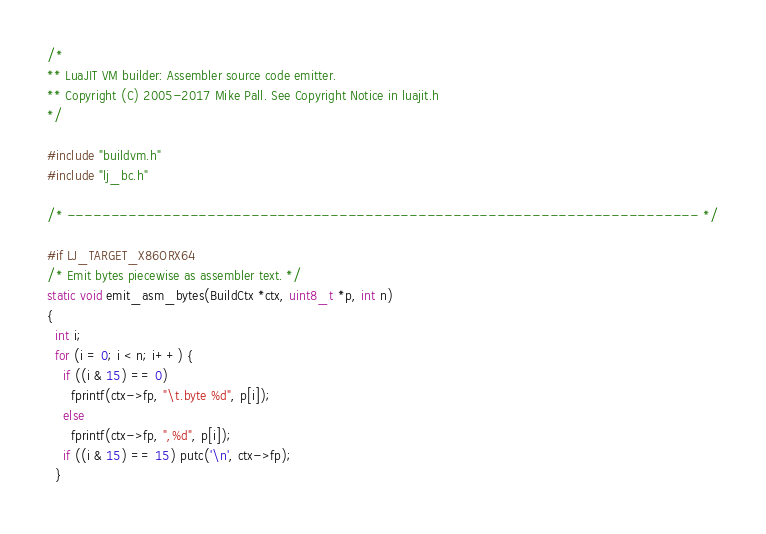Convert code to text. <code><loc_0><loc_0><loc_500><loc_500><_C_>/*
** LuaJIT VM builder: Assembler source code emitter.
** Copyright (C) 2005-2017 Mike Pall. See Copyright Notice in luajit.h
*/

#include "buildvm.h"
#include "lj_bc.h"

/* ------------------------------------------------------------------------ */

#if LJ_TARGET_X86ORX64
/* Emit bytes piecewise as assembler text. */
static void emit_asm_bytes(BuildCtx *ctx, uint8_t *p, int n)
{
  int i;
  for (i = 0; i < n; i++) {
    if ((i & 15) == 0)
      fprintf(ctx->fp, "\t.byte %d", p[i]);
    else
      fprintf(ctx->fp, ",%d", p[i]);
    if ((i & 15) == 15) putc('\n', ctx->fp);
  }</code> 